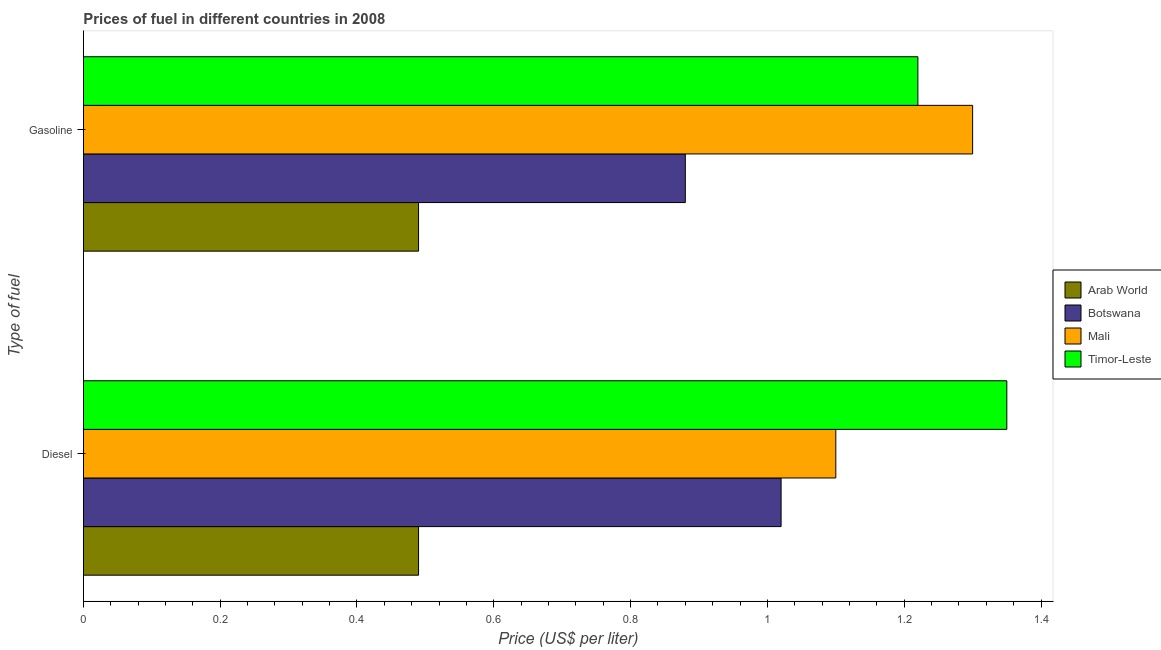How many groups of bars are there?
Offer a terse response. 2. Are the number of bars per tick equal to the number of legend labels?
Provide a short and direct response. Yes. Are the number of bars on each tick of the Y-axis equal?
Your answer should be very brief. Yes. How many bars are there on the 1st tick from the bottom?
Ensure brevity in your answer.  4. What is the label of the 2nd group of bars from the top?
Make the answer very short. Diesel. What is the diesel price in Arab World?
Your answer should be very brief. 0.49. Across all countries, what is the maximum gasoline price?
Provide a short and direct response. 1.3. Across all countries, what is the minimum gasoline price?
Keep it short and to the point. 0.49. In which country was the diesel price maximum?
Offer a terse response. Timor-Leste. In which country was the gasoline price minimum?
Make the answer very short. Arab World. What is the total gasoline price in the graph?
Ensure brevity in your answer.  3.89. What is the difference between the gasoline price in Arab World and that in Botswana?
Provide a short and direct response. -0.39. What is the difference between the gasoline price in Arab World and the diesel price in Timor-Leste?
Offer a very short reply. -0.86. What is the average gasoline price per country?
Give a very brief answer. 0.97. What is the difference between the gasoline price and diesel price in Mali?
Offer a terse response. 0.2. In how many countries, is the gasoline price greater than 0.7200000000000001 US$ per litre?
Offer a very short reply. 3. What is the ratio of the gasoline price in Timor-Leste to that in Arab World?
Your answer should be very brief. 2.49. In how many countries, is the diesel price greater than the average diesel price taken over all countries?
Your answer should be compact. 3. What does the 2nd bar from the top in Diesel represents?
Ensure brevity in your answer.  Mali. What does the 1st bar from the bottom in Diesel represents?
Make the answer very short. Arab World. How many bars are there?
Your response must be concise. 8. Does the graph contain any zero values?
Offer a very short reply. No. How many legend labels are there?
Provide a short and direct response. 4. How are the legend labels stacked?
Offer a very short reply. Vertical. What is the title of the graph?
Ensure brevity in your answer.  Prices of fuel in different countries in 2008. What is the label or title of the X-axis?
Your answer should be compact. Price (US$ per liter). What is the label or title of the Y-axis?
Provide a short and direct response. Type of fuel. What is the Price (US$ per liter) of Arab World in Diesel?
Ensure brevity in your answer.  0.49. What is the Price (US$ per liter) in Timor-Leste in Diesel?
Give a very brief answer. 1.35. What is the Price (US$ per liter) in Arab World in Gasoline?
Your response must be concise. 0.49. What is the Price (US$ per liter) in Timor-Leste in Gasoline?
Offer a terse response. 1.22. Across all Type of fuel, what is the maximum Price (US$ per liter) in Arab World?
Offer a terse response. 0.49. Across all Type of fuel, what is the maximum Price (US$ per liter) in Mali?
Provide a succinct answer. 1.3. Across all Type of fuel, what is the maximum Price (US$ per liter) of Timor-Leste?
Make the answer very short. 1.35. Across all Type of fuel, what is the minimum Price (US$ per liter) of Arab World?
Your answer should be compact. 0.49. Across all Type of fuel, what is the minimum Price (US$ per liter) in Botswana?
Provide a short and direct response. 0.88. Across all Type of fuel, what is the minimum Price (US$ per liter) of Mali?
Provide a succinct answer. 1.1. Across all Type of fuel, what is the minimum Price (US$ per liter) in Timor-Leste?
Give a very brief answer. 1.22. What is the total Price (US$ per liter) in Mali in the graph?
Give a very brief answer. 2.4. What is the total Price (US$ per liter) in Timor-Leste in the graph?
Keep it short and to the point. 2.57. What is the difference between the Price (US$ per liter) in Arab World in Diesel and that in Gasoline?
Your response must be concise. 0. What is the difference between the Price (US$ per liter) of Botswana in Diesel and that in Gasoline?
Provide a succinct answer. 0.14. What is the difference between the Price (US$ per liter) of Mali in Diesel and that in Gasoline?
Provide a short and direct response. -0.2. What is the difference between the Price (US$ per liter) of Timor-Leste in Diesel and that in Gasoline?
Your answer should be compact. 0.13. What is the difference between the Price (US$ per liter) of Arab World in Diesel and the Price (US$ per liter) of Botswana in Gasoline?
Your answer should be compact. -0.39. What is the difference between the Price (US$ per liter) in Arab World in Diesel and the Price (US$ per liter) in Mali in Gasoline?
Your response must be concise. -0.81. What is the difference between the Price (US$ per liter) of Arab World in Diesel and the Price (US$ per liter) of Timor-Leste in Gasoline?
Provide a succinct answer. -0.73. What is the difference between the Price (US$ per liter) in Botswana in Diesel and the Price (US$ per liter) in Mali in Gasoline?
Keep it short and to the point. -0.28. What is the difference between the Price (US$ per liter) in Mali in Diesel and the Price (US$ per liter) in Timor-Leste in Gasoline?
Your answer should be very brief. -0.12. What is the average Price (US$ per liter) in Arab World per Type of fuel?
Provide a succinct answer. 0.49. What is the average Price (US$ per liter) in Botswana per Type of fuel?
Offer a terse response. 0.95. What is the average Price (US$ per liter) in Mali per Type of fuel?
Give a very brief answer. 1.2. What is the average Price (US$ per liter) of Timor-Leste per Type of fuel?
Your answer should be very brief. 1.28. What is the difference between the Price (US$ per liter) of Arab World and Price (US$ per liter) of Botswana in Diesel?
Your response must be concise. -0.53. What is the difference between the Price (US$ per liter) in Arab World and Price (US$ per liter) in Mali in Diesel?
Provide a succinct answer. -0.61. What is the difference between the Price (US$ per liter) in Arab World and Price (US$ per liter) in Timor-Leste in Diesel?
Make the answer very short. -0.86. What is the difference between the Price (US$ per liter) of Botswana and Price (US$ per liter) of Mali in Diesel?
Offer a very short reply. -0.08. What is the difference between the Price (US$ per liter) of Botswana and Price (US$ per liter) of Timor-Leste in Diesel?
Offer a very short reply. -0.33. What is the difference between the Price (US$ per liter) of Mali and Price (US$ per liter) of Timor-Leste in Diesel?
Your answer should be very brief. -0.25. What is the difference between the Price (US$ per liter) in Arab World and Price (US$ per liter) in Botswana in Gasoline?
Your answer should be very brief. -0.39. What is the difference between the Price (US$ per liter) in Arab World and Price (US$ per liter) in Mali in Gasoline?
Provide a succinct answer. -0.81. What is the difference between the Price (US$ per liter) of Arab World and Price (US$ per liter) of Timor-Leste in Gasoline?
Give a very brief answer. -0.73. What is the difference between the Price (US$ per liter) of Botswana and Price (US$ per liter) of Mali in Gasoline?
Your answer should be compact. -0.42. What is the difference between the Price (US$ per liter) of Botswana and Price (US$ per liter) of Timor-Leste in Gasoline?
Provide a succinct answer. -0.34. What is the ratio of the Price (US$ per liter) of Arab World in Diesel to that in Gasoline?
Your answer should be very brief. 1. What is the ratio of the Price (US$ per liter) of Botswana in Diesel to that in Gasoline?
Your response must be concise. 1.16. What is the ratio of the Price (US$ per liter) of Mali in Diesel to that in Gasoline?
Make the answer very short. 0.85. What is the ratio of the Price (US$ per liter) in Timor-Leste in Diesel to that in Gasoline?
Offer a terse response. 1.11. What is the difference between the highest and the second highest Price (US$ per liter) of Arab World?
Your response must be concise. 0. What is the difference between the highest and the second highest Price (US$ per liter) of Botswana?
Ensure brevity in your answer.  0.14. What is the difference between the highest and the second highest Price (US$ per liter) of Mali?
Your answer should be compact. 0.2. What is the difference between the highest and the second highest Price (US$ per liter) in Timor-Leste?
Ensure brevity in your answer.  0.13. What is the difference between the highest and the lowest Price (US$ per liter) in Botswana?
Your answer should be compact. 0.14. What is the difference between the highest and the lowest Price (US$ per liter) of Timor-Leste?
Your answer should be very brief. 0.13. 